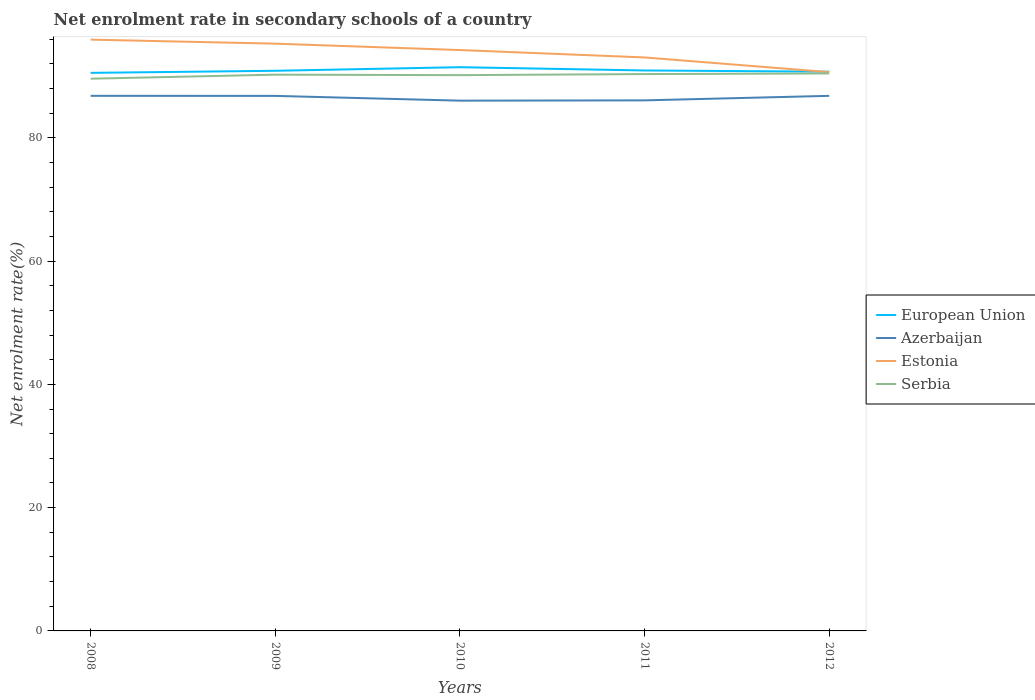How many different coloured lines are there?
Provide a short and direct response. 4. Does the line corresponding to Estonia intersect with the line corresponding to European Union?
Your response must be concise. Yes. Is the number of lines equal to the number of legend labels?
Provide a short and direct response. Yes. Across all years, what is the maximum net enrolment rate in secondary schools in European Union?
Your answer should be very brief. 90.54. In which year was the net enrolment rate in secondary schools in Azerbaijan maximum?
Your answer should be compact. 2010. What is the total net enrolment rate in secondary schools in European Union in the graph?
Provide a succinct answer. 0.15. What is the difference between the highest and the second highest net enrolment rate in secondary schools in Serbia?
Provide a short and direct response. 0.85. What is the difference between the highest and the lowest net enrolment rate in secondary schools in Estonia?
Offer a very short reply. 3. Is the net enrolment rate in secondary schools in European Union strictly greater than the net enrolment rate in secondary schools in Serbia over the years?
Ensure brevity in your answer.  No. How many lines are there?
Offer a terse response. 4. What is the difference between two consecutive major ticks on the Y-axis?
Offer a terse response. 20. Are the values on the major ticks of Y-axis written in scientific E-notation?
Keep it short and to the point. No. Does the graph contain any zero values?
Give a very brief answer. No. Does the graph contain grids?
Give a very brief answer. No. How are the legend labels stacked?
Keep it short and to the point. Vertical. What is the title of the graph?
Provide a succinct answer. Net enrolment rate in secondary schools of a country. Does "Greenland" appear as one of the legend labels in the graph?
Provide a succinct answer. No. What is the label or title of the Y-axis?
Offer a terse response. Net enrolment rate(%). What is the Net enrolment rate(%) in European Union in 2008?
Provide a succinct answer. 90.54. What is the Net enrolment rate(%) in Azerbaijan in 2008?
Give a very brief answer. 86.81. What is the Net enrolment rate(%) in Estonia in 2008?
Offer a very short reply. 95.93. What is the Net enrolment rate(%) of Serbia in 2008?
Offer a very short reply. 89.59. What is the Net enrolment rate(%) in European Union in 2009?
Your answer should be compact. 90.87. What is the Net enrolment rate(%) of Azerbaijan in 2009?
Make the answer very short. 86.8. What is the Net enrolment rate(%) in Estonia in 2009?
Your answer should be very brief. 95.27. What is the Net enrolment rate(%) of Serbia in 2009?
Your answer should be very brief. 90.24. What is the Net enrolment rate(%) in European Union in 2010?
Give a very brief answer. 91.46. What is the Net enrolment rate(%) in Azerbaijan in 2010?
Offer a terse response. 86.03. What is the Net enrolment rate(%) in Estonia in 2010?
Provide a short and direct response. 94.24. What is the Net enrolment rate(%) of Serbia in 2010?
Your answer should be compact. 90.17. What is the Net enrolment rate(%) in European Union in 2011?
Keep it short and to the point. 90.92. What is the Net enrolment rate(%) of Azerbaijan in 2011?
Give a very brief answer. 86.07. What is the Net enrolment rate(%) of Estonia in 2011?
Your response must be concise. 93.04. What is the Net enrolment rate(%) in Serbia in 2011?
Your response must be concise. 90.34. What is the Net enrolment rate(%) in European Union in 2012?
Offer a terse response. 90.73. What is the Net enrolment rate(%) of Azerbaijan in 2012?
Ensure brevity in your answer.  86.81. What is the Net enrolment rate(%) of Estonia in 2012?
Offer a terse response. 90.65. What is the Net enrolment rate(%) in Serbia in 2012?
Ensure brevity in your answer.  90.44. Across all years, what is the maximum Net enrolment rate(%) in European Union?
Provide a succinct answer. 91.46. Across all years, what is the maximum Net enrolment rate(%) of Azerbaijan?
Your answer should be compact. 86.81. Across all years, what is the maximum Net enrolment rate(%) of Estonia?
Provide a succinct answer. 95.93. Across all years, what is the maximum Net enrolment rate(%) in Serbia?
Your response must be concise. 90.44. Across all years, what is the minimum Net enrolment rate(%) of European Union?
Offer a terse response. 90.54. Across all years, what is the minimum Net enrolment rate(%) in Azerbaijan?
Your response must be concise. 86.03. Across all years, what is the minimum Net enrolment rate(%) of Estonia?
Your answer should be very brief. 90.65. Across all years, what is the minimum Net enrolment rate(%) in Serbia?
Offer a very short reply. 89.59. What is the total Net enrolment rate(%) in European Union in the graph?
Your response must be concise. 454.52. What is the total Net enrolment rate(%) in Azerbaijan in the graph?
Your response must be concise. 432.52. What is the total Net enrolment rate(%) of Estonia in the graph?
Provide a succinct answer. 469.12. What is the total Net enrolment rate(%) in Serbia in the graph?
Ensure brevity in your answer.  450.77. What is the difference between the Net enrolment rate(%) in European Union in 2008 and that in 2009?
Provide a succinct answer. -0.34. What is the difference between the Net enrolment rate(%) of Azerbaijan in 2008 and that in 2009?
Give a very brief answer. 0.01. What is the difference between the Net enrolment rate(%) of Estonia in 2008 and that in 2009?
Your response must be concise. 0.65. What is the difference between the Net enrolment rate(%) in Serbia in 2008 and that in 2009?
Keep it short and to the point. -0.65. What is the difference between the Net enrolment rate(%) in European Union in 2008 and that in 2010?
Your answer should be compact. -0.92. What is the difference between the Net enrolment rate(%) in Azerbaijan in 2008 and that in 2010?
Offer a very short reply. 0.78. What is the difference between the Net enrolment rate(%) of Estonia in 2008 and that in 2010?
Offer a very short reply. 1.69. What is the difference between the Net enrolment rate(%) of Serbia in 2008 and that in 2010?
Provide a succinct answer. -0.58. What is the difference between the Net enrolment rate(%) of European Union in 2008 and that in 2011?
Your response must be concise. -0.39. What is the difference between the Net enrolment rate(%) in Azerbaijan in 2008 and that in 2011?
Offer a very short reply. 0.74. What is the difference between the Net enrolment rate(%) of Estonia in 2008 and that in 2011?
Your answer should be very brief. 2.89. What is the difference between the Net enrolment rate(%) in Serbia in 2008 and that in 2011?
Offer a very short reply. -0.75. What is the difference between the Net enrolment rate(%) of European Union in 2008 and that in 2012?
Offer a very short reply. -0.19. What is the difference between the Net enrolment rate(%) in Azerbaijan in 2008 and that in 2012?
Keep it short and to the point. 0. What is the difference between the Net enrolment rate(%) of Estonia in 2008 and that in 2012?
Make the answer very short. 5.28. What is the difference between the Net enrolment rate(%) in Serbia in 2008 and that in 2012?
Offer a terse response. -0.85. What is the difference between the Net enrolment rate(%) in European Union in 2009 and that in 2010?
Keep it short and to the point. -0.58. What is the difference between the Net enrolment rate(%) in Azerbaijan in 2009 and that in 2010?
Your response must be concise. 0.77. What is the difference between the Net enrolment rate(%) of Estonia in 2009 and that in 2010?
Keep it short and to the point. 1.04. What is the difference between the Net enrolment rate(%) in Serbia in 2009 and that in 2010?
Give a very brief answer. 0.07. What is the difference between the Net enrolment rate(%) in European Union in 2009 and that in 2011?
Offer a terse response. -0.05. What is the difference between the Net enrolment rate(%) in Azerbaijan in 2009 and that in 2011?
Provide a succinct answer. 0.72. What is the difference between the Net enrolment rate(%) of Estonia in 2009 and that in 2011?
Keep it short and to the point. 2.24. What is the difference between the Net enrolment rate(%) in Serbia in 2009 and that in 2011?
Give a very brief answer. -0.1. What is the difference between the Net enrolment rate(%) of European Union in 2009 and that in 2012?
Make the answer very short. 0.15. What is the difference between the Net enrolment rate(%) in Azerbaijan in 2009 and that in 2012?
Provide a short and direct response. -0.01. What is the difference between the Net enrolment rate(%) in Estonia in 2009 and that in 2012?
Ensure brevity in your answer.  4.62. What is the difference between the Net enrolment rate(%) in Serbia in 2009 and that in 2012?
Your response must be concise. -0.2. What is the difference between the Net enrolment rate(%) in European Union in 2010 and that in 2011?
Give a very brief answer. 0.53. What is the difference between the Net enrolment rate(%) of Azerbaijan in 2010 and that in 2011?
Keep it short and to the point. -0.05. What is the difference between the Net enrolment rate(%) of Estonia in 2010 and that in 2011?
Give a very brief answer. 1.2. What is the difference between the Net enrolment rate(%) of Serbia in 2010 and that in 2011?
Provide a short and direct response. -0.17. What is the difference between the Net enrolment rate(%) of European Union in 2010 and that in 2012?
Your answer should be compact. 0.73. What is the difference between the Net enrolment rate(%) in Azerbaijan in 2010 and that in 2012?
Your response must be concise. -0.78. What is the difference between the Net enrolment rate(%) of Estonia in 2010 and that in 2012?
Your response must be concise. 3.58. What is the difference between the Net enrolment rate(%) of Serbia in 2010 and that in 2012?
Ensure brevity in your answer.  -0.27. What is the difference between the Net enrolment rate(%) in European Union in 2011 and that in 2012?
Provide a short and direct response. 0.2. What is the difference between the Net enrolment rate(%) of Azerbaijan in 2011 and that in 2012?
Your answer should be compact. -0.73. What is the difference between the Net enrolment rate(%) in Estonia in 2011 and that in 2012?
Provide a short and direct response. 2.39. What is the difference between the Net enrolment rate(%) in European Union in 2008 and the Net enrolment rate(%) in Azerbaijan in 2009?
Offer a terse response. 3.74. What is the difference between the Net enrolment rate(%) in European Union in 2008 and the Net enrolment rate(%) in Estonia in 2009?
Your answer should be very brief. -4.74. What is the difference between the Net enrolment rate(%) in European Union in 2008 and the Net enrolment rate(%) in Serbia in 2009?
Give a very brief answer. 0.3. What is the difference between the Net enrolment rate(%) of Azerbaijan in 2008 and the Net enrolment rate(%) of Estonia in 2009?
Offer a very short reply. -8.46. What is the difference between the Net enrolment rate(%) of Azerbaijan in 2008 and the Net enrolment rate(%) of Serbia in 2009?
Make the answer very short. -3.43. What is the difference between the Net enrolment rate(%) in Estonia in 2008 and the Net enrolment rate(%) in Serbia in 2009?
Your answer should be very brief. 5.69. What is the difference between the Net enrolment rate(%) in European Union in 2008 and the Net enrolment rate(%) in Azerbaijan in 2010?
Your answer should be very brief. 4.51. What is the difference between the Net enrolment rate(%) in European Union in 2008 and the Net enrolment rate(%) in Estonia in 2010?
Make the answer very short. -3.7. What is the difference between the Net enrolment rate(%) in European Union in 2008 and the Net enrolment rate(%) in Serbia in 2010?
Your answer should be compact. 0.37. What is the difference between the Net enrolment rate(%) of Azerbaijan in 2008 and the Net enrolment rate(%) of Estonia in 2010?
Give a very brief answer. -7.43. What is the difference between the Net enrolment rate(%) of Azerbaijan in 2008 and the Net enrolment rate(%) of Serbia in 2010?
Offer a very short reply. -3.36. What is the difference between the Net enrolment rate(%) in Estonia in 2008 and the Net enrolment rate(%) in Serbia in 2010?
Keep it short and to the point. 5.76. What is the difference between the Net enrolment rate(%) of European Union in 2008 and the Net enrolment rate(%) of Azerbaijan in 2011?
Provide a short and direct response. 4.46. What is the difference between the Net enrolment rate(%) of European Union in 2008 and the Net enrolment rate(%) of Estonia in 2011?
Provide a succinct answer. -2.5. What is the difference between the Net enrolment rate(%) of European Union in 2008 and the Net enrolment rate(%) of Serbia in 2011?
Provide a short and direct response. 0.2. What is the difference between the Net enrolment rate(%) of Azerbaijan in 2008 and the Net enrolment rate(%) of Estonia in 2011?
Ensure brevity in your answer.  -6.23. What is the difference between the Net enrolment rate(%) of Azerbaijan in 2008 and the Net enrolment rate(%) of Serbia in 2011?
Provide a succinct answer. -3.53. What is the difference between the Net enrolment rate(%) in Estonia in 2008 and the Net enrolment rate(%) in Serbia in 2011?
Offer a very short reply. 5.59. What is the difference between the Net enrolment rate(%) of European Union in 2008 and the Net enrolment rate(%) of Azerbaijan in 2012?
Ensure brevity in your answer.  3.73. What is the difference between the Net enrolment rate(%) in European Union in 2008 and the Net enrolment rate(%) in Estonia in 2012?
Your response must be concise. -0.12. What is the difference between the Net enrolment rate(%) in European Union in 2008 and the Net enrolment rate(%) in Serbia in 2012?
Offer a very short reply. 0.1. What is the difference between the Net enrolment rate(%) of Azerbaijan in 2008 and the Net enrolment rate(%) of Estonia in 2012?
Provide a short and direct response. -3.84. What is the difference between the Net enrolment rate(%) of Azerbaijan in 2008 and the Net enrolment rate(%) of Serbia in 2012?
Ensure brevity in your answer.  -3.63. What is the difference between the Net enrolment rate(%) of Estonia in 2008 and the Net enrolment rate(%) of Serbia in 2012?
Give a very brief answer. 5.49. What is the difference between the Net enrolment rate(%) of European Union in 2009 and the Net enrolment rate(%) of Azerbaijan in 2010?
Ensure brevity in your answer.  4.85. What is the difference between the Net enrolment rate(%) of European Union in 2009 and the Net enrolment rate(%) of Estonia in 2010?
Give a very brief answer. -3.36. What is the difference between the Net enrolment rate(%) of European Union in 2009 and the Net enrolment rate(%) of Serbia in 2010?
Provide a succinct answer. 0.71. What is the difference between the Net enrolment rate(%) in Azerbaijan in 2009 and the Net enrolment rate(%) in Estonia in 2010?
Provide a short and direct response. -7.44. What is the difference between the Net enrolment rate(%) of Azerbaijan in 2009 and the Net enrolment rate(%) of Serbia in 2010?
Ensure brevity in your answer.  -3.37. What is the difference between the Net enrolment rate(%) of Estonia in 2009 and the Net enrolment rate(%) of Serbia in 2010?
Give a very brief answer. 5.11. What is the difference between the Net enrolment rate(%) of European Union in 2009 and the Net enrolment rate(%) of Azerbaijan in 2011?
Keep it short and to the point. 4.8. What is the difference between the Net enrolment rate(%) in European Union in 2009 and the Net enrolment rate(%) in Estonia in 2011?
Offer a terse response. -2.16. What is the difference between the Net enrolment rate(%) in European Union in 2009 and the Net enrolment rate(%) in Serbia in 2011?
Offer a terse response. 0.54. What is the difference between the Net enrolment rate(%) of Azerbaijan in 2009 and the Net enrolment rate(%) of Estonia in 2011?
Offer a very short reply. -6.24. What is the difference between the Net enrolment rate(%) in Azerbaijan in 2009 and the Net enrolment rate(%) in Serbia in 2011?
Your answer should be very brief. -3.54. What is the difference between the Net enrolment rate(%) of Estonia in 2009 and the Net enrolment rate(%) of Serbia in 2011?
Your response must be concise. 4.93. What is the difference between the Net enrolment rate(%) in European Union in 2009 and the Net enrolment rate(%) in Azerbaijan in 2012?
Offer a very short reply. 4.07. What is the difference between the Net enrolment rate(%) in European Union in 2009 and the Net enrolment rate(%) in Estonia in 2012?
Make the answer very short. 0.22. What is the difference between the Net enrolment rate(%) of European Union in 2009 and the Net enrolment rate(%) of Serbia in 2012?
Ensure brevity in your answer.  0.44. What is the difference between the Net enrolment rate(%) in Azerbaijan in 2009 and the Net enrolment rate(%) in Estonia in 2012?
Your answer should be very brief. -3.85. What is the difference between the Net enrolment rate(%) in Azerbaijan in 2009 and the Net enrolment rate(%) in Serbia in 2012?
Your response must be concise. -3.64. What is the difference between the Net enrolment rate(%) in Estonia in 2009 and the Net enrolment rate(%) in Serbia in 2012?
Your response must be concise. 4.83. What is the difference between the Net enrolment rate(%) of European Union in 2010 and the Net enrolment rate(%) of Azerbaijan in 2011?
Your answer should be very brief. 5.38. What is the difference between the Net enrolment rate(%) in European Union in 2010 and the Net enrolment rate(%) in Estonia in 2011?
Offer a very short reply. -1.58. What is the difference between the Net enrolment rate(%) of European Union in 2010 and the Net enrolment rate(%) of Serbia in 2011?
Give a very brief answer. 1.12. What is the difference between the Net enrolment rate(%) in Azerbaijan in 2010 and the Net enrolment rate(%) in Estonia in 2011?
Provide a succinct answer. -7.01. What is the difference between the Net enrolment rate(%) of Azerbaijan in 2010 and the Net enrolment rate(%) of Serbia in 2011?
Ensure brevity in your answer.  -4.31. What is the difference between the Net enrolment rate(%) in Estonia in 2010 and the Net enrolment rate(%) in Serbia in 2011?
Provide a succinct answer. 3.9. What is the difference between the Net enrolment rate(%) in European Union in 2010 and the Net enrolment rate(%) in Azerbaijan in 2012?
Keep it short and to the point. 4.65. What is the difference between the Net enrolment rate(%) of European Union in 2010 and the Net enrolment rate(%) of Estonia in 2012?
Your answer should be compact. 0.8. What is the difference between the Net enrolment rate(%) in European Union in 2010 and the Net enrolment rate(%) in Serbia in 2012?
Make the answer very short. 1.02. What is the difference between the Net enrolment rate(%) in Azerbaijan in 2010 and the Net enrolment rate(%) in Estonia in 2012?
Give a very brief answer. -4.62. What is the difference between the Net enrolment rate(%) in Azerbaijan in 2010 and the Net enrolment rate(%) in Serbia in 2012?
Your answer should be very brief. -4.41. What is the difference between the Net enrolment rate(%) of Estonia in 2010 and the Net enrolment rate(%) of Serbia in 2012?
Ensure brevity in your answer.  3.8. What is the difference between the Net enrolment rate(%) in European Union in 2011 and the Net enrolment rate(%) in Azerbaijan in 2012?
Give a very brief answer. 4.12. What is the difference between the Net enrolment rate(%) in European Union in 2011 and the Net enrolment rate(%) in Estonia in 2012?
Make the answer very short. 0.27. What is the difference between the Net enrolment rate(%) in European Union in 2011 and the Net enrolment rate(%) in Serbia in 2012?
Your answer should be very brief. 0.48. What is the difference between the Net enrolment rate(%) of Azerbaijan in 2011 and the Net enrolment rate(%) of Estonia in 2012?
Ensure brevity in your answer.  -4.58. What is the difference between the Net enrolment rate(%) in Azerbaijan in 2011 and the Net enrolment rate(%) in Serbia in 2012?
Keep it short and to the point. -4.36. What is the difference between the Net enrolment rate(%) of Estonia in 2011 and the Net enrolment rate(%) of Serbia in 2012?
Give a very brief answer. 2.6. What is the average Net enrolment rate(%) in European Union per year?
Make the answer very short. 90.9. What is the average Net enrolment rate(%) in Azerbaijan per year?
Ensure brevity in your answer.  86.5. What is the average Net enrolment rate(%) in Estonia per year?
Your answer should be compact. 93.83. What is the average Net enrolment rate(%) of Serbia per year?
Offer a very short reply. 90.15. In the year 2008, what is the difference between the Net enrolment rate(%) of European Union and Net enrolment rate(%) of Azerbaijan?
Give a very brief answer. 3.73. In the year 2008, what is the difference between the Net enrolment rate(%) in European Union and Net enrolment rate(%) in Estonia?
Offer a terse response. -5.39. In the year 2008, what is the difference between the Net enrolment rate(%) of European Union and Net enrolment rate(%) of Serbia?
Give a very brief answer. 0.95. In the year 2008, what is the difference between the Net enrolment rate(%) of Azerbaijan and Net enrolment rate(%) of Estonia?
Keep it short and to the point. -9.12. In the year 2008, what is the difference between the Net enrolment rate(%) of Azerbaijan and Net enrolment rate(%) of Serbia?
Ensure brevity in your answer.  -2.78. In the year 2008, what is the difference between the Net enrolment rate(%) of Estonia and Net enrolment rate(%) of Serbia?
Offer a terse response. 6.34. In the year 2009, what is the difference between the Net enrolment rate(%) in European Union and Net enrolment rate(%) in Azerbaijan?
Offer a terse response. 4.08. In the year 2009, what is the difference between the Net enrolment rate(%) of European Union and Net enrolment rate(%) of Estonia?
Offer a terse response. -4.4. In the year 2009, what is the difference between the Net enrolment rate(%) of European Union and Net enrolment rate(%) of Serbia?
Provide a short and direct response. 0.63. In the year 2009, what is the difference between the Net enrolment rate(%) of Azerbaijan and Net enrolment rate(%) of Estonia?
Offer a very short reply. -8.47. In the year 2009, what is the difference between the Net enrolment rate(%) of Azerbaijan and Net enrolment rate(%) of Serbia?
Your response must be concise. -3.44. In the year 2009, what is the difference between the Net enrolment rate(%) of Estonia and Net enrolment rate(%) of Serbia?
Offer a very short reply. 5.03. In the year 2010, what is the difference between the Net enrolment rate(%) in European Union and Net enrolment rate(%) in Azerbaijan?
Keep it short and to the point. 5.43. In the year 2010, what is the difference between the Net enrolment rate(%) in European Union and Net enrolment rate(%) in Estonia?
Your answer should be compact. -2.78. In the year 2010, what is the difference between the Net enrolment rate(%) of European Union and Net enrolment rate(%) of Serbia?
Your response must be concise. 1.29. In the year 2010, what is the difference between the Net enrolment rate(%) of Azerbaijan and Net enrolment rate(%) of Estonia?
Provide a succinct answer. -8.21. In the year 2010, what is the difference between the Net enrolment rate(%) in Azerbaijan and Net enrolment rate(%) in Serbia?
Make the answer very short. -4.14. In the year 2010, what is the difference between the Net enrolment rate(%) of Estonia and Net enrolment rate(%) of Serbia?
Provide a short and direct response. 4.07. In the year 2011, what is the difference between the Net enrolment rate(%) in European Union and Net enrolment rate(%) in Azerbaijan?
Keep it short and to the point. 4.85. In the year 2011, what is the difference between the Net enrolment rate(%) of European Union and Net enrolment rate(%) of Estonia?
Make the answer very short. -2.11. In the year 2011, what is the difference between the Net enrolment rate(%) of European Union and Net enrolment rate(%) of Serbia?
Keep it short and to the point. 0.58. In the year 2011, what is the difference between the Net enrolment rate(%) in Azerbaijan and Net enrolment rate(%) in Estonia?
Offer a very short reply. -6.96. In the year 2011, what is the difference between the Net enrolment rate(%) in Azerbaijan and Net enrolment rate(%) in Serbia?
Ensure brevity in your answer.  -4.26. In the year 2011, what is the difference between the Net enrolment rate(%) of Estonia and Net enrolment rate(%) of Serbia?
Keep it short and to the point. 2.7. In the year 2012, what is the difference between the Net enrolment rate(%) of European Union and Net enrolment rate(%) of Azerbaijan?
Give a very brief answer. 3.92. In the year 2012, what is the difference between the Net enrolment rate(%) in European Union and Net enrolment rate(%) in Estonia?
Keep it short and to the point. 0.07. In the year 2012, what is the difference between the Net enrolment rate(%) of European Union and Net enrolment rate(%) of Serbia?
Offer a terse response. 0.29. In the year 2012, what is the difference between the Net enrolment rate(%) in Azerbaijan and Net enrolment rate(%) in Estonia?
Your response must be concise. -3.84. In the year 2012, what is the difference between the Net enrolment rate(%) in Azerbaijan and Net enrolment rate(%) in Serbia?
Offer a very short reply. -3.63. In the year 2012, what is the difference between the Net enrolment rate(%) of Estonia and Net enrolment rate(%) of Serbia?
Offer a very short reply. 0.21. What is the ratio of the Net enrolment rate(%) of Estonia in 2008 to that in 2009?
Give a very brief answer. 1.01. What is the ratio of the Net enrolment rate(%) in Serbia in 2008 to that in 2009?
Ensure brevity in your answer.  0.99. What is the ratio of the Net enrolment rate(%) in Azerbaijan in 2008 to that in 2010?
Your answer should be very brief. 1.01. What is the ratio of the Net enrolment rate(%) of Estonia in 2008 to that in 2010?
Offer a terse response. 1.02. What is the ratio of the Net enrolment rate(%) in Serbia in 2008 to that in 2010?
Your answer should be compact. 0.99. What is the ratio of the Net enrolment rate(%) of Azerbaijan in 2008 to that in 2011?
Make the answer very short. 1.01. What is the ratio of the Net enrolment rate(%) of Estonia in 2008 to that in 2011?
Keep it short and to the point. 1.03. What is the ratio of the Net enrolment rate(%) of Serbia in 2008 to that in 2011?
Your response must be concise. 0.99. What is the ratio of the Net enrolment rate(%) of European Union in 2008 to that in 2012?
Offer a terse response. 1. What is the ratio of the Net enrolment rate(%) in Azerbaijan in 2008 to that in 2012?
Provide a short and direct response. 1. What is the ratio of the Net enrolment rate(%) of Estonia in 2008 to that in 2012?
Offer a terse response. 1.06. What is the ratio of the Net enrolment rate(%) of Serbia in 2008 to that in 2012?
Ensure brevity in your answer.  0.99. What is the ratio of the Net enrolment rate(%) in Azerbaijan in 2009 to that in 2010?
Keep it short and to the point. 1.01. What is the ratio of the Net enrolment rate(%) in Estonia in 2009 to that in 2010?
Your answer should be compact. 1.01. What is the ratio of the Net enrolment rate(%) of European Union in 2009 to that in 2011?
Your response must be concise. 1. What is the ratio of the Net enrolment rate(%) of Azerbaijan in 2009 to that in 2011?
Give a very brief answer. 1.01. What is the ratio of the Net enrolment rate(%) of Estonia in 2009 to that in 2011?
Your response must be concise. 1.02. What is the ratio of the Net enrolment rate(%) of Serbia in 2009 to that in 2011?
Make the answer very short. 1. What is the ratio of the Net enrolment rate(%) of Azerbaijan in 2009 to that in 2012?
Make the answer very short. 1. What is the ratio of the Net enrolment rate(%) in Estonia in 2009 to that in 2012?
Your response must be concise. 1.05. What is the ratio of the Net enrolment rate(%) in European Union in 2010 to that in 2011?
Make the answer very short. 1.01. What is the ratio of the Net enrolment rate(%) in Estonia in 2010 to that in 2011?
Keep it short and to the point. 1.01. What is the ratio of the Net enrolment rate(%) in Serbia in 2010 to that in 2011?
Provide a succinct answer. 1. What is the ratio of the Net enrolment rate(%) in European Union in 2010 to that in 2012?
Give a very brief answer. 1.01. What is the ratio of the Net enrolment rate(%) in Estonia in 2010 to that in 2012?
Give a very brief answer. 1.04. What is the ratio of the Net enrolment rate(%) in Serbia in 2010 to that in 2012?
Offer a very short reply. 1. What is the ratio of the Net enrolment rate(%) in Azerbaijan in 2011 to that in 2012?
Provide a succinct answer. 0.99. What is the ratio of the Net enrolment rate(%) of Estonia in 2011 to that in 2012?
Ensure brevity in your answer.  1.03. What is the difference between the highest and the second highest Net enrolment rate(%) in European Union?
Ensure brevity in your answer.  0.53. What is the difference between the highest and the second highest Net enrolment rate(%) of Azerbaijan?
Keep it short and to the point. 0. What is the difference between the highest and the second highest Net enrolment rate(%) of Estonia?
Ensure brevity in your answer.  0.65. What is the difference between the highest and the lowest Net enrolment rate(%) in European Union?
Make the answer very short. 0.92. What is the difference between the highest and the lowest Net enrolment rate(%) in Azerbaijan?
Make the answer very short. 0.78. What is the difference between the highest and the lowest Net enrolment rate(%) of Estonia?
Provide a succinct answer. 5.28. What is the difference between the highest and the lowest Net enrolment rate(%) in Serbia?
Provide a succinct answer. 0.85. 